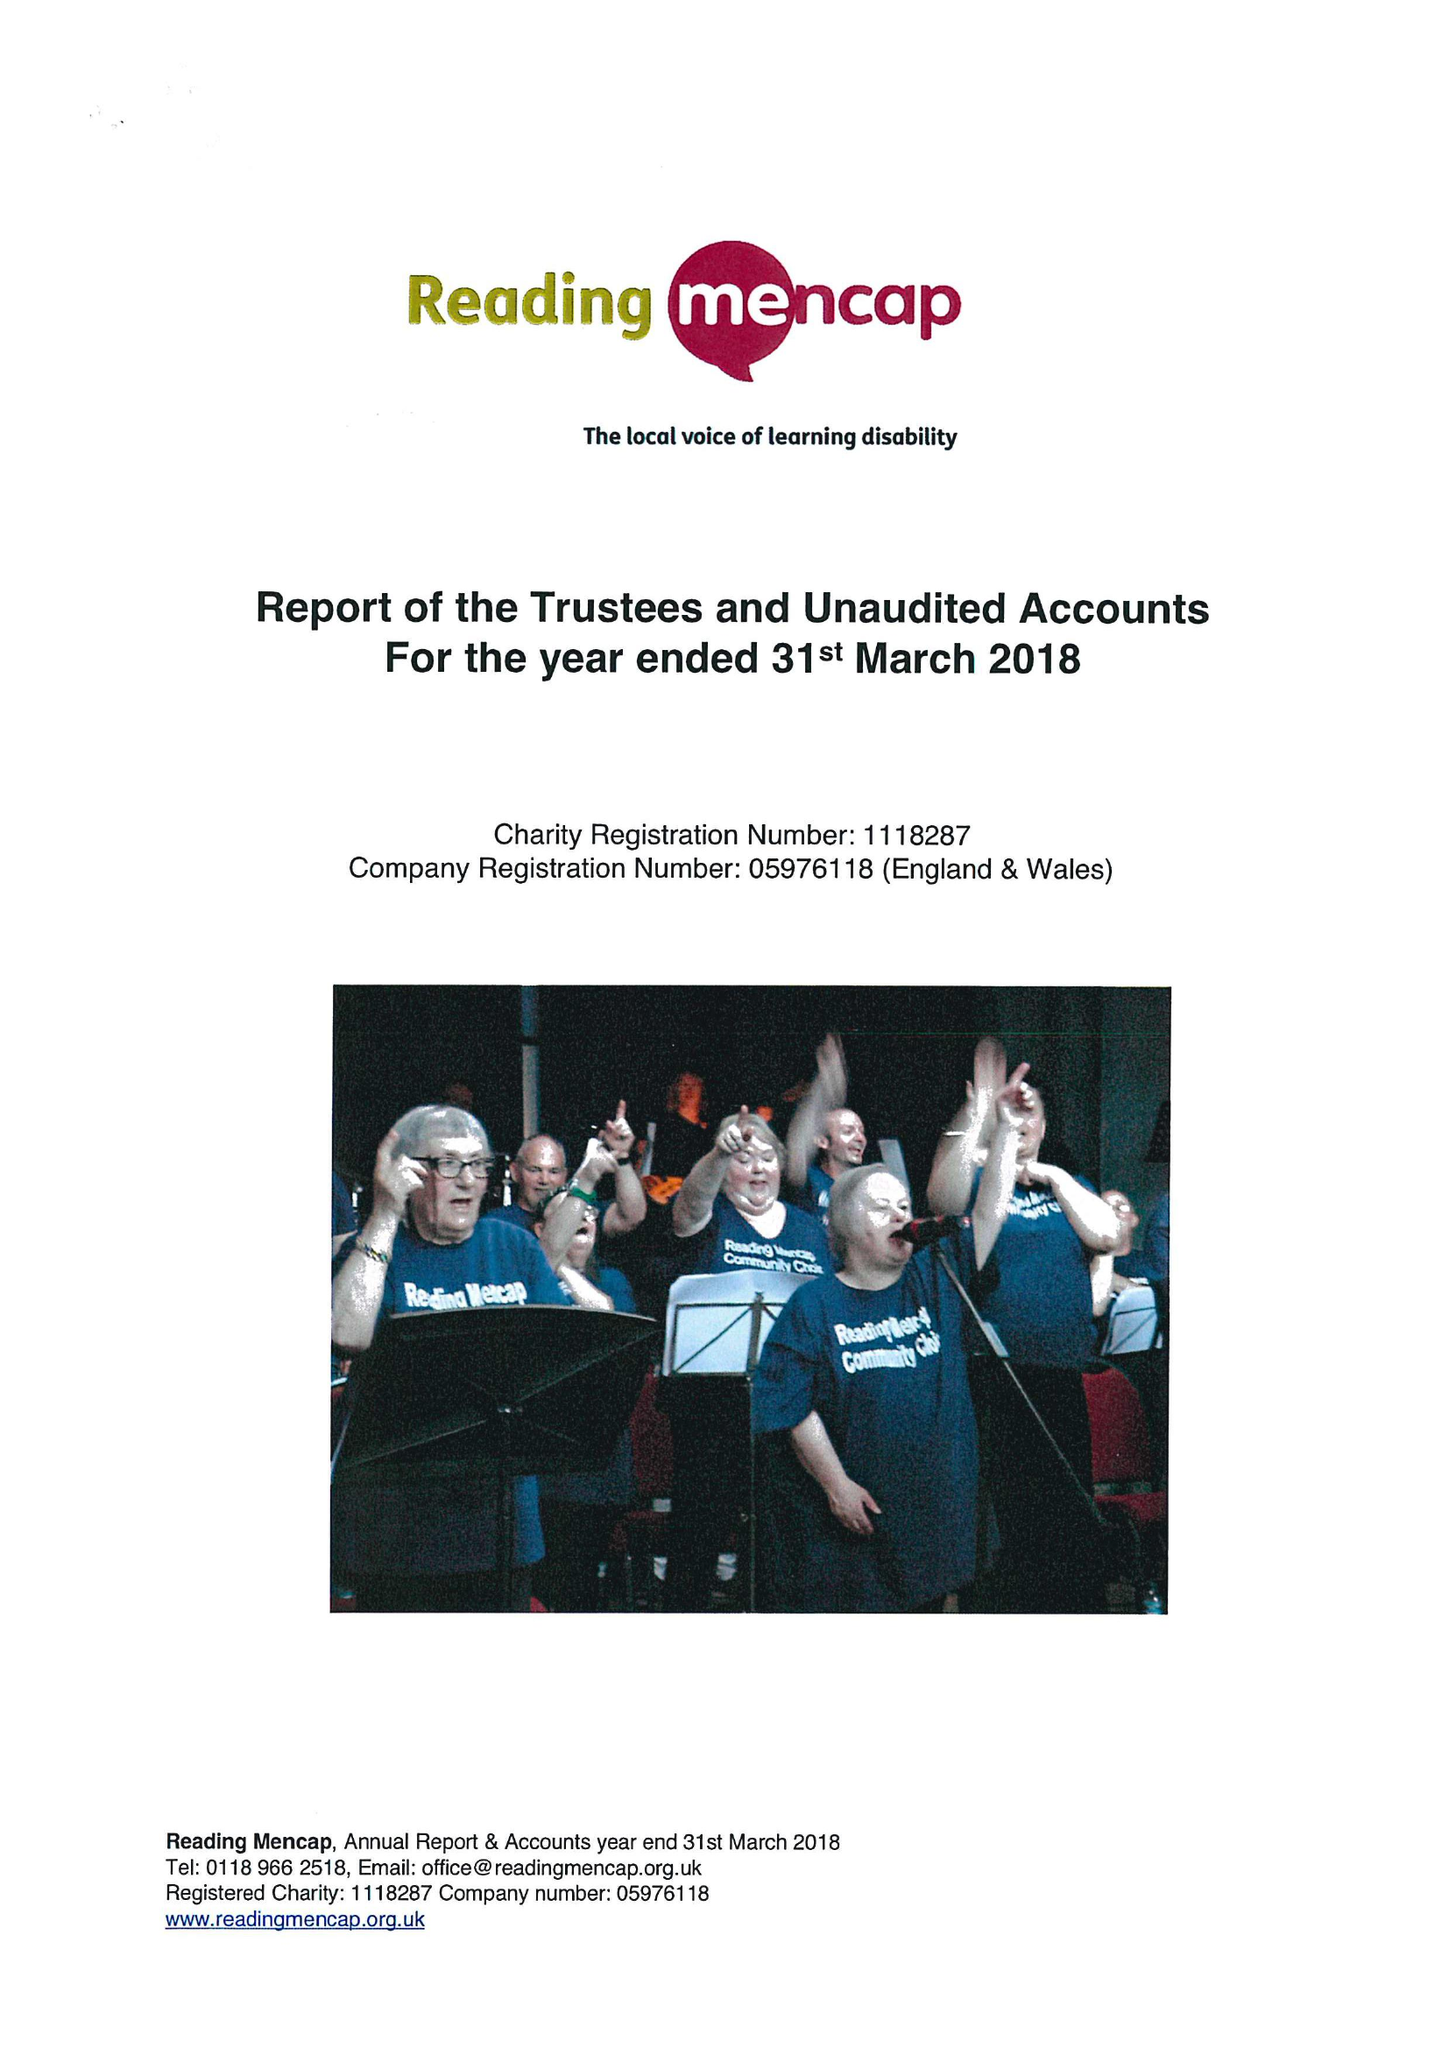What is the value for the charity_name?
Answer the question using a single word or phrase. Reading Mencap 